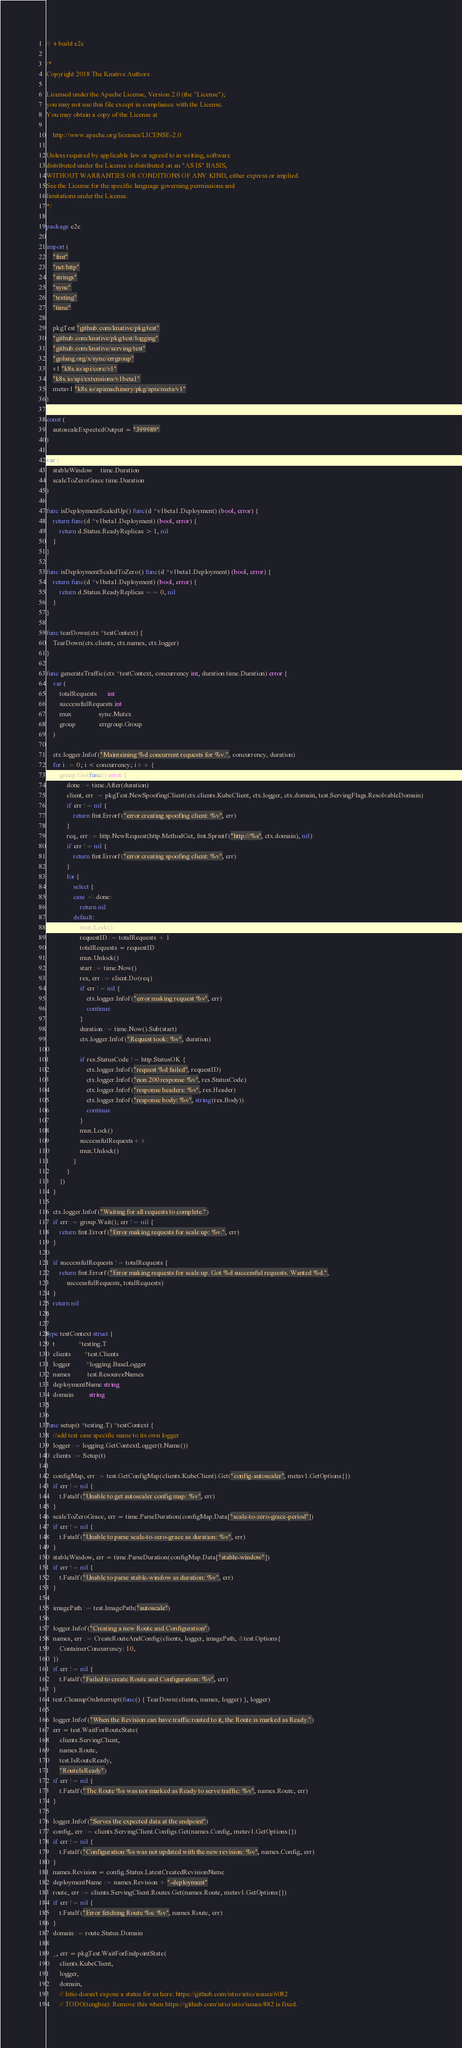<code> <loc_0><loc_0><loc_500><loc_500><_Go_>// +build e2e

/*
Copyright 2018 The Knative Authors

Licensed under the Apache License, Version 2.0 (the "License");
you may not use this file except in compliance with the License.
You may obtain a copy of the License at

    http://www.apache.org/licenses/LICENSE-2.0

Unless required by applicable law or agreed to in writing, software
distributed under the License is distributed on an "AS IS" BASIS,
WITHOUT WARRANTIES OR CONDITIONS OF ANY KIND, either express or implied.
See the License for the specific language governing permissions and
limitations under the License.
*/

package e2e

import (
	"fmt"
	"net/http"
	"strings"
	"sync"
	"testing"
	"time"

	pkgTest "github.com/knative/pkg/test"
	"github.com/knative/pkg/test/logging"
	"github.com/knative/serving/test"
	"golang.org/x/sync/errgroup"
	v1 "k8s.io/api/core/v1"
	"k8s.io/api/extensions/v1beta1"
	metav1 "k8s.io/apimachinery/pkg/apis/meta/v1"
)

const (
	autoscaleExpectedOutput = "399989"
)

var (
	stableWindow     time.Duration
	scaleToZeroGrace time.Duration
)

func isDeploymentScaledUp() func(d *v1beta1.Deployment) (bool, error) {
	return func(d *v1beta1.Deployment) (bool, error) {
		return d.Status.ReadyReplicas > 1, nil
	}
}

func isDeploymentScaledToZero() func(d *v1beta1.Deployment) (bool, error) {
	return func(d *v1beta1.Deployment) (bool, error) {
		return d.Status.ReadyReplicas == 0, nil
	}
}

func tearDown(ctx *testContext) {
	TearDown(ctx.clients, ctx.names, ctx.logger)
}

func generateTraffic(ctx *testContext, concurrency int, duration time.Duration) error {
	var (
		totalRequests      int
		successfulRequests int
		mux                sync.Mutex
		group              errgroup.Group
	)

	ctx.logger.Infof("Maintaining %d concurrent requests for %v.", concurrency, duration)
	for i := 0; i < concurrency; i++ {
		group.Go(func() error {
			done := time.After(duration)
			client, err := pkgTest.NewSpoofingClient(ctx.clients.KubeClient, ctx.logger, ctx.domain, test.ServingFlags.ResolvableDomain)
			if err != nil {
				return fmt.Errorf("error creating spoofing client: %v", err)
			}
			req, err := http.NewRequest(http.MethodGet, fmt.Sprintf("http://%s", ctx.domain), nil)
			if err != nil {
				return fmt.Errorf("error creating spoofing client: %v", err)
			}
			for {
				select {
				case <-done:
					return nil
				default:
					mux.Lock()
					requestID := totalRequests + 1
					totalRequests = requestID
					mux.Unlock()
					start := time.Now()
					res, err := client.Do(req)
					if err != nil {
						ctx.logger.Infof("error making request %v", err)
						continue
					}
					duration := time.Now().Sub(start)
					ctx.logger.Infof("Request took: %v", duration)

					if res.StatusCode != http.StatusOK {
						ctx.logger.Infof("request %d failed", requestID)
						ctx.logger.Infof("non 200 response %v", res.StatusCode)
						ctx.logger.Infof("response headers: %v", res.Header)
						ctx.logger.Infof("response body: %v", string(res.Body))
						continue
					}
					mux.Lock()
					successfulRequests++
					mux.Unlock()
				}
			}
		})
	}

	ctx.logger.Infof("Waiting for all requests to complete.")
	if err := group.Wait(); err != nil {
		return fmt.Errorf("Error making requests for scale up: %v.", err)
	}

	if successfulRequests != totalRequests {
		return fmt.Errorf("Error making requests for scale up. Got %d successful requests. Wanted %d.",
			successfulRequests, totalRequests)
	}
	return nil
}

type testContext struct {
	t              *testing.T
	clients        *test.Clients
	logger         *logging.BaseLogger
	names          test.ResourceNames
	deploymentName string
	domain         string
}

func setup(t *testing.T) *testContext {
	//add test case specific name to its own logger
	logger := logging.GetContextLogger(t.Name())
	clients := Setup(t)

	configMap, err := test.GetConfigMap(clients.KubeClient).Get("config-autoscaler", metav1.GetOptions{})
	if err != nil {
		t.Fatalf("Unable to get autoscaler config map: %v", err)
	}
	scaleToZeroGrace, err = time.ParseDuration(configMap.Data["scale-to-zero-grace-period"])
	if err != nil {
		t.Fatalf("Unable to parse scale-to-zero-grace as duration: %v", err)
	}
	stableWindow, err = time.ParseDuration(configMap.Data["stable-window"])
	if err != nil {
		t.Fatalf("Unable to parse stable-window as duration: %v", err)
	}

	imagePath := test.ImagePath("autoscale")

	logger.Infof("Creating a new Route and Configuration")
	names, err := CreateRouteAndConfig(clients, logger, imagePath, &test.Options{
		ContainerConcurrency: 10,
	})
	if err != nil {
		t.Fatalf("Failed to create Route and Configuration: %v", err)
	}
	test.CleanupOnInterrupt(func() { TearDown(clients, names, logger) }, logger)

	logger.Infof("When the Revision can have traffic routed to it, the Route is marked as Ready.")
	err = test.WaitForRouteState(
		clients.ServingClient,
		names.Route,
		test.IsRouteReady,
		"RouteIsReady")
	if err != nil {
		t.Fatalf("The Route %s was not marked as Ready to serve traffic: %v", names.Route, err)
	}

	logger.Infof("Serves the expected data at the endpoint")
	config, err := clients.ServingClient.Configs.Get(names.Config, metav1.GetOptions{})
	if err != nil {
		t.Fatalf("Configuration %s was not updated with the new revision: %v", names.Config, err)
	}
	names.Revision = config.Status.LatestCreatedRevisionName
	deploymentName := names.Revision + "-deployment"
	route, err := clients.ServingClient.Routes.Get(names.Route, metav1.GetOptions{})
	if err != nil {
		t.Fatalf("Error fetching Route %s: %v", names.Route, err)
	}
	domain := route.Status.Domain

	_, err = pkgTest.WaitForEndpointState(
		clients.KubeClient,
		logger,
		domain,
		// Istio doesn't expose a status for us here: https://github.com/istio/istio/issues/6082
		// TODO(tcnghia): Remove this when https://github.com/istio/istio/issues/882 is fixed.</code> 